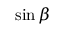<formula> <loc_0><loc_0><loc_500><loc_500>\sin \beta</formula> 